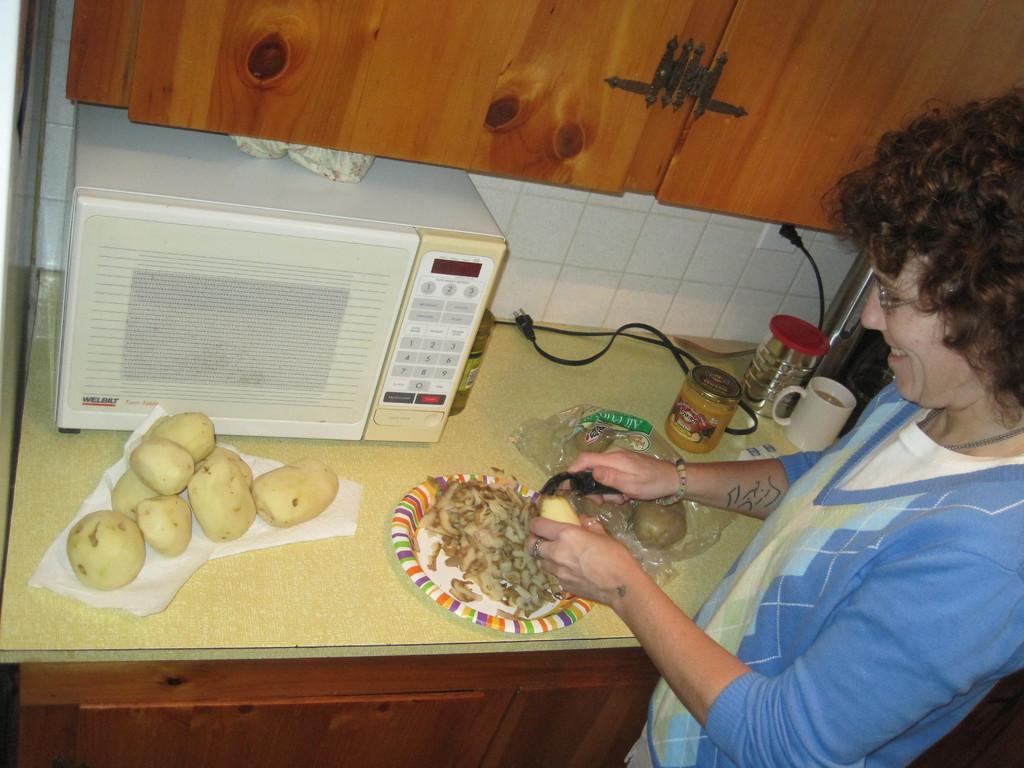Please provide a concise description of this image. In this image I see the counter top on which there is an oven over here and I see few jars, a cup, wires, potatoes on this white color thing and I see a plate which is colorful and I see brown color things on it and I see a cover on which there are few more potatoes and I see a woman over here who is holding a black color thing and a potato in her hands. In the background I see the marble wall and I see the cupboards over here. 